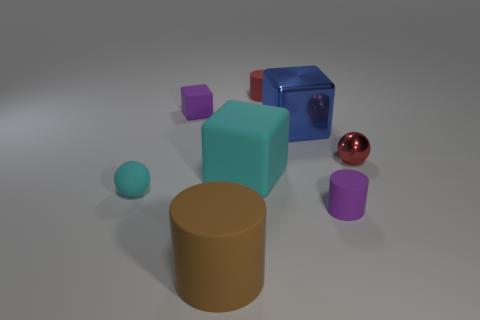Subtract all large cyan matte cubes. How many cubes are left? 2 Add 2 small purple things. How many objects exist? 10 Subtract all cylinders. How many objects are left? 5 Subtract 2 cylinders. How many cylinders are left? 1 Subtract all big brown spheres. Subtract all large cyan matte cubes. How many objects are left? 7 Add 8 big cylinders. How many big cylinders are left? 9 Add 8 big cyan objects. How many big cyan objects exist? 9 Subtract 0 brown cubes. How many objects are left? 8 Subtract all purple cubes. Subtract all gray spheres. How many cubes are left? 2 